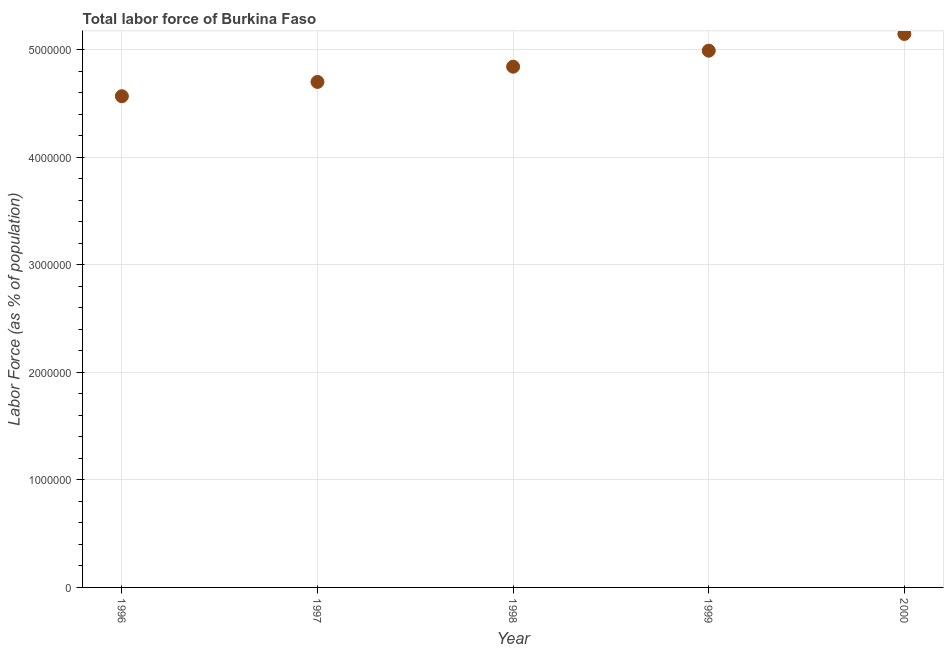What is the total labor force in 1999?
Give a very brief answer. 4.99e+06. Across all years, what is the maximum total labor force?
Your response must be concise. 5.15e+06. Across all years, what is the minimum total labor force?
Offer a very short reply. 4.57e+06. What is the sum of the total labor force?
Provide a succinct answer. 2.42e+07. What is the difference between the total labor force in 1997 and 1999?
Ensure brevity in your answer.  -2.91e+05. What is the average total labor force per year?
Ensure brevity in your answer.  4.85e+06. What is the median total labor force?
Ensure brevity in your answer.  4.84e+06. In how many years, is the total labor force greater than 4000000 %?
Your answer should be compact. 5. Do a majority of the years between 1998 and 1996 (inclusive) have total labor force greater than 1000000 %?
Your answer should be very brief. No. What is the ratio of the total labor force in 1996 to that in 1997?
Offer a very short reply. 0.97. Is the total labor force in 1998 less than that in 1999?
Offer a very short reply. Yes. What is the difference between the highest and the second highest total labor force?
Make the answer very short. 1.56e+05. Is the sum of the total labor force in 1997 and 1999 greater than the maximum total labor force across all years?
Your answer should be very brief. Yes. What is the difference between the highest and the lowest total labor force?
Provide a succinct answer. 5.79e+05. What is the difference between two consecutive major ticks on the Y-axis?
Offer a very short reply. 1.00e+06. Does the graph contain any zero values?
Provide a short and direct response. No. Does the graph contain grids?
Keep it short and to the point. Yes. What is the title of the graph?
Ensure brevity in your answer.  Total labor force of Burkina Faso. What is the label or title of the X-axis?
Offer a terse response. Year. What is the label or title of the Y-axis?
Your answer should be compact. Labor Force (as % of population). What is the Labor Force (as % of population) in 1996?
Offer a terse response. 4.57e+06. What is the Labor Force (as % of population) in 1997?
Your answer should be compact. 4.70e+06. What is the Labor Force (as % of population) in 1998?
Your answer should be compact. 4.84e+06. What is the Labor Force (as % of population) in 1999?
Your response must be concise. 4.99e+06. What is the Labor Force (as % of population) in 2000?
Your answer should be compact. 5.15e+06. What is the difference between the Labor Force (as % of population) in 1996 and 1997?
Keep it short and to the point. -1.33e+05. What is the difference between the Labor Force (as % of population) in 1996 and 1998?
Give a very brief answer. -2.75e+05. What is the difference between the Labor Force (as % of population) in 1996 and 1999?
Keep it short and to the point. -4.24e+05. What is the difference between the Labor Force (as % of population) in 1996 and 2000?
Your response must be concise. -5.79e+05. What is the difference between the Labor Force (as % of population) in 1997 and 1998?
Provide a short and direct response. -1.42e+05. What is the difference between the Labor Force (as % of population) in 1997 and 1999?
Offer a very short reply. -2.91e+05. What is the difference between the Labor Force (as % of population) in 1997 and 2000?
Give a very brief answer. -4.46e+05. What is the difference between the Labor Force (as % of population) in 1998 and 1999?
Your answer should be compact. -1.49e+05. What is the difference between the Labor Force (as % of population) in 1998 and 2000?
Your answer should be compact. -3.05e+05. What is the difference between the Labor Force (as % of population) in 1999 and 2000?
Your response must be concise. -1.56e+05. What is the ratio of the Labor Force (as % of population) in 1996 to that in 1997?
Provide a short and direct response. 0.97. What is the ratio of the Labor Force (as % of population) in 1996 to that in 1998?
Keep it short and to the point. 0.94. What is the ratio of the Labor Force (as % of population) in 1996 to that in 1999?
Offer a terse response. 0.92. What is the ratio of the Labor Force (as % of population) in 1996 to that in 2000?
Your response must be concise. 0.89. What is the ratio of the Labor Force (as % of population) in 1997 to that in 1999?
Keep it short and to the point. 0.94. What is the ratio of the Labor Force (as % of population) in 1998 to that in 2000?
Your answer should be compact. 0.94. 